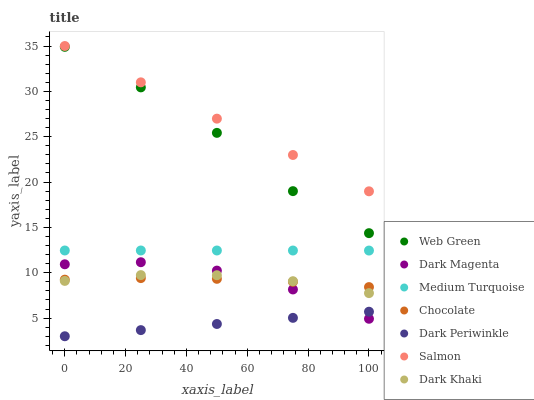Does Dark Periwinkle have the minimum area under the curve?
Answer yes or no. Yes. Does Salmon have the maximum area under the curve?
Answer yes or no. Yes. Does Web Green have the minimum area under the curve?
Answer yes or no. No. Does Web Green have the maximum area under the curve?
Answer yes or no. No. Is Dark Periwinkle the smoothest?
Answer yes or no. Yes. Is Web Green the roughest?
Answer yes or no. Yes. Is Salmon the smoothest?
Answer yes or no. No. Is Salmon the roughest?
Answer yes or no. No. Does Dark Periwinkle have the lowest value?
Answer yes or no. Yes. Does Web Green have the lowest value?
Answer yes or no. No. Does Salmon have the highest value?
Answer yes or no. Yes. Does Web Green have the highest value?
Answer yes or no. No. Is Dark Periwinkle less than Chocolate?
Answer yes or no. Yes. Is Salmon greater than Dark Periwinkle?
Answer yes or no. Yes. Does Chocolate intersect Dark Magenta?
Answer yes or no. Yes. Is Chocolate less than Dark Magenta?
Answer yes or no. No. Is Chocolate greater than Dark Magenta?
Answer yes or no. No. Does Dark Periwinkle intersect Chocolate?
Answer yes or no. No. 